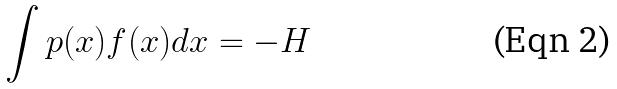Convert formula to latex. <formula><loc_0><loc_0><loc_500><loc_500>\int p ( x ) f ( x ) d x = - H</formula> 